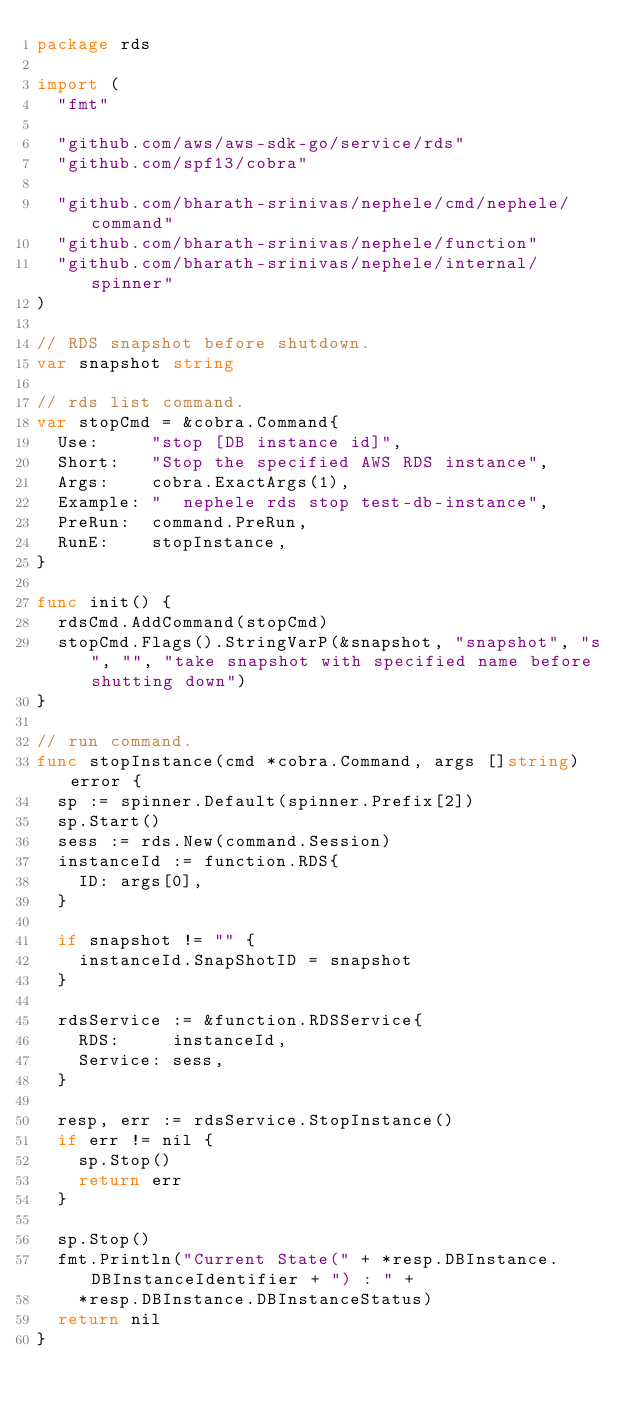<code> <loc_0><loc_0><loc_500><loc_500><_Go_>package rds

import (
	"fmt"

	"github.com/aws/aws-sdk-go/service/rds"
	"github.com/spf13/cobra"

	"github.com/bharath-srinivas/nephele/cmd/nephele/command"
	"github.com/bharath-srinivas/nephele/function"
	"github.com/bharath-srinivas/nephele/internal/spinner"
)

// RDS snapshot before shutdown.
var snapshot string

// rds list command.
var stopCmd = &cobra.Command{
	Use:     "stop [DB instance id]",
	Short:   "Stop the specified AWS RDS instance",
	Args:    cobra.ExactArgs(1),
	Example: "  nephele rds stop test-db-instance",
	PreRun:  command.PreRun,
	RunE:    stopInstance,
}

func init() {
	rdsCmd.AddCommand(stopCmd)
	stopCmd.Flags().StringVarP(&snapshot, "snapshot", "s", "", "take snapshot with specified name before shutting down")
}

// run command.
func stopInstance(cmd *cobra.Command, args []string) error {
	sp := spinner.Default(spinner.Prefix[2])
	sp.Start()
	sess := rds.New(command.Session)
	instanceId := function.RDS{
		ID: args[0],
	}

	if snapshot != "" {
		instanceId.SnapShotID = snapshot
	}

	rdsService := &function.RDSService{
		RDS:     instanceId,
		Service: sess,
	}

	resp, err := rdsService.StopInstance()
	if err != nil {
		sp.Stop()
		return err
	}

	sp.Stop()
	fmt.Println("Current State(" + *resp.DBInstance.DBInstanceIdentifier + ") : " +
		*resp.DBInstance.DBInstanceStatus)
	return nil
}
</code> 